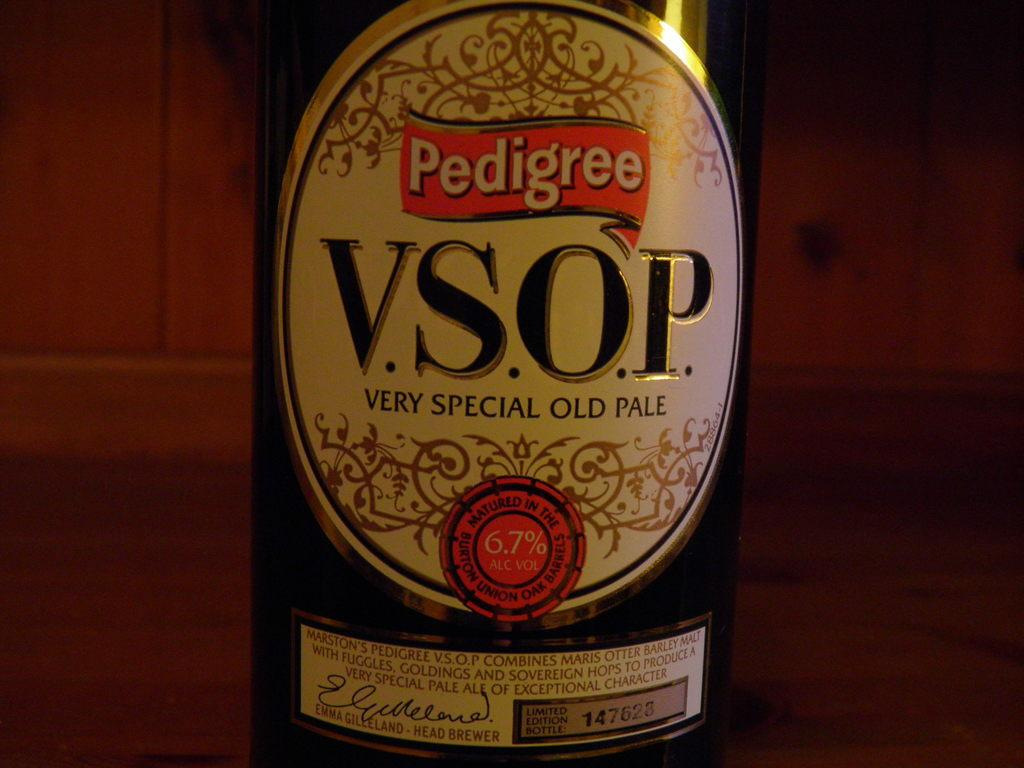<image>
Create a compact narrative representing the image presented. A bottle of Pedigree Very Special Old Ale stands. 